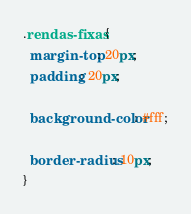Convert code to text. <code><loc_0><loc_0><loc_500><loc_500><_CSS_>.rendas-fixas {
  margin-top: 20px;
  padding: 20px;

  background-color: #fff;

  border-radius: 10px;
}
</code> 